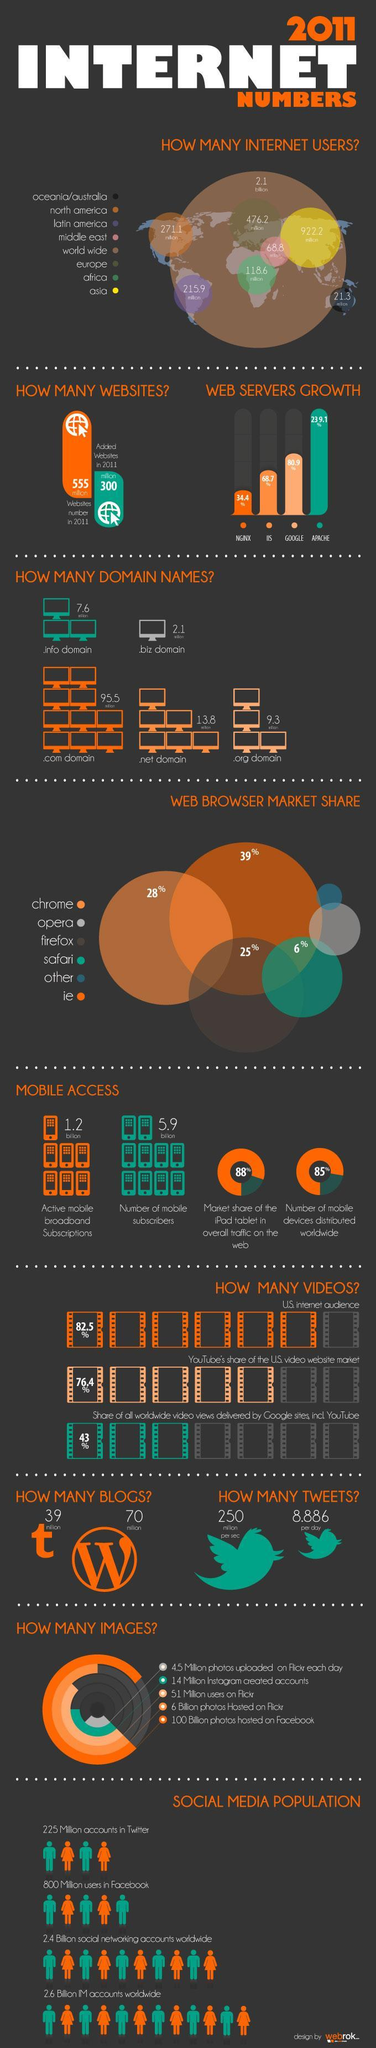What was the web servers growth percentage on Google?
Answer the question with a short phrase. 80.9% Which continent had 21.3 million internet users in 2011? Oceania/ Australia What was the number (in millions) of .com domain names? 95.5 Which web browser has the third highest market share %? firefox Which continent had higher number of internet users in 2011 - Europe, Latin America or North America? Europe Which web browser has the second highest market share %? chrome Which domain had 13.8 million registrations in 2011? .net domain What was the number of internet users (in millions) in Asia in 2011? 922.2 million What was the market share % of ie web browser? 39 What was the number (in billions) of mobile subscribers in 2011? 5.9 billion 